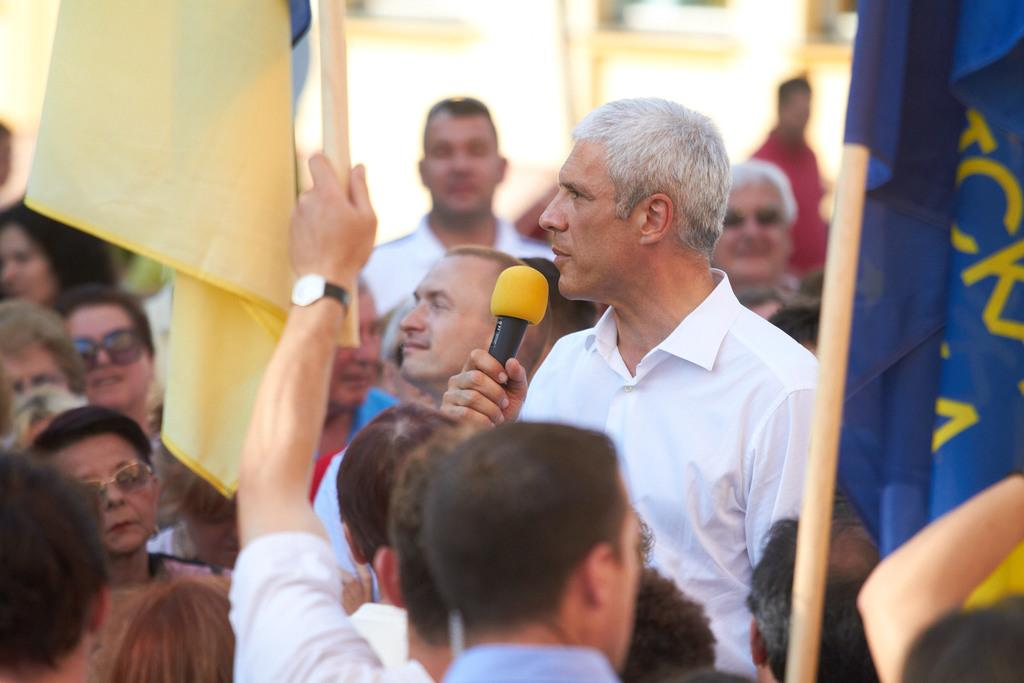What can be seen in the image that represents a symbol or country? There is a flag in the image. Are there any people present in the image? Yes, there are people standing in the image. What object is being held by a man in the image? A man is holding a microphone in the image. What type of texture can be seen on the flag in the image? The provided facts do not mention any specific texture on the flag, so it cannot be determined from the image. Is there any bait present in the image? There is no mention of bait in the provided facts, and it is not visible in the image. 